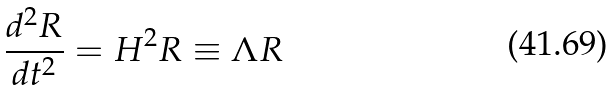<formula> <loc_0><loc_0><loc_500><loc_500>\frac { d ^ { 2 } R } { d t ^ { 2 } } = H ^ { 2 } R \equiv \Lambda R</formula> 